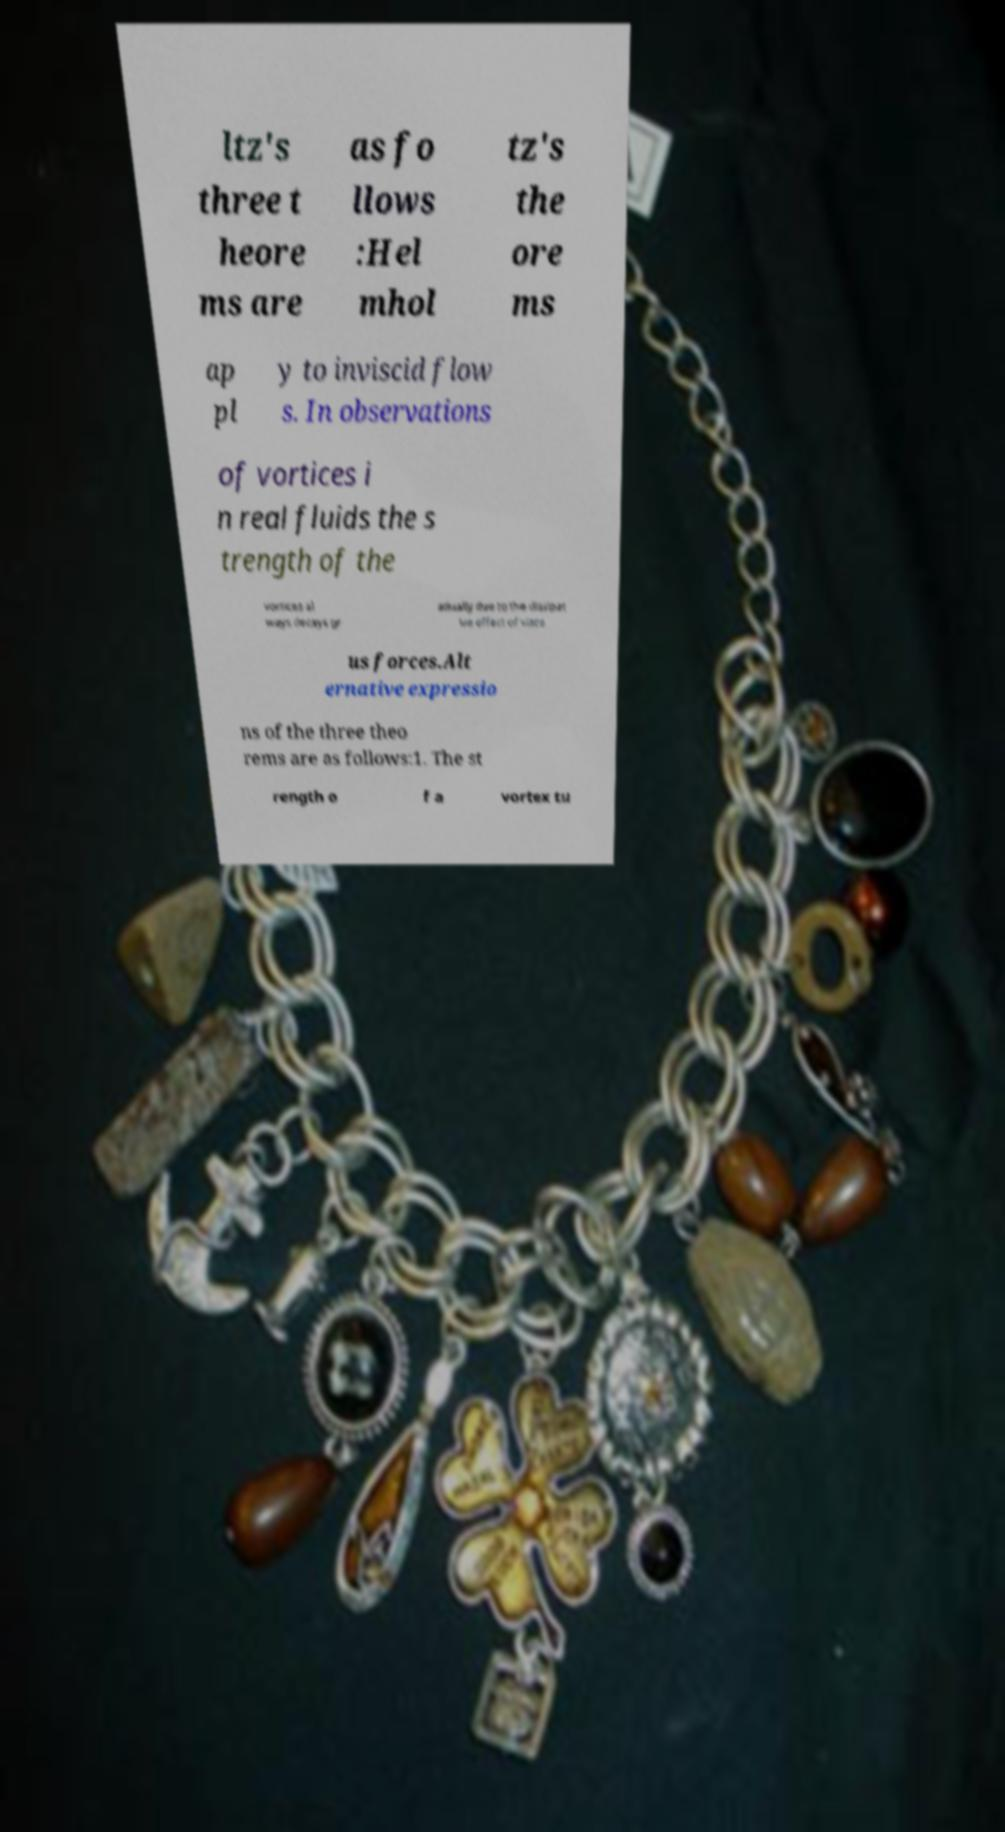Could you assist in decoding the text presented in this image and type it out clearly? ltz's three t heore ms are as fo llows :Hel mhol tz's the ore ms ap pl y to inviscid flow s. In observations of vortices i n real fluids the s trength of the vortices al ways decays gr adually due to the dissipat ive effect of visco us forces.Alt ernative expressio ns of the three theo rems are as follows:1. The st rength o f a vortex tu 